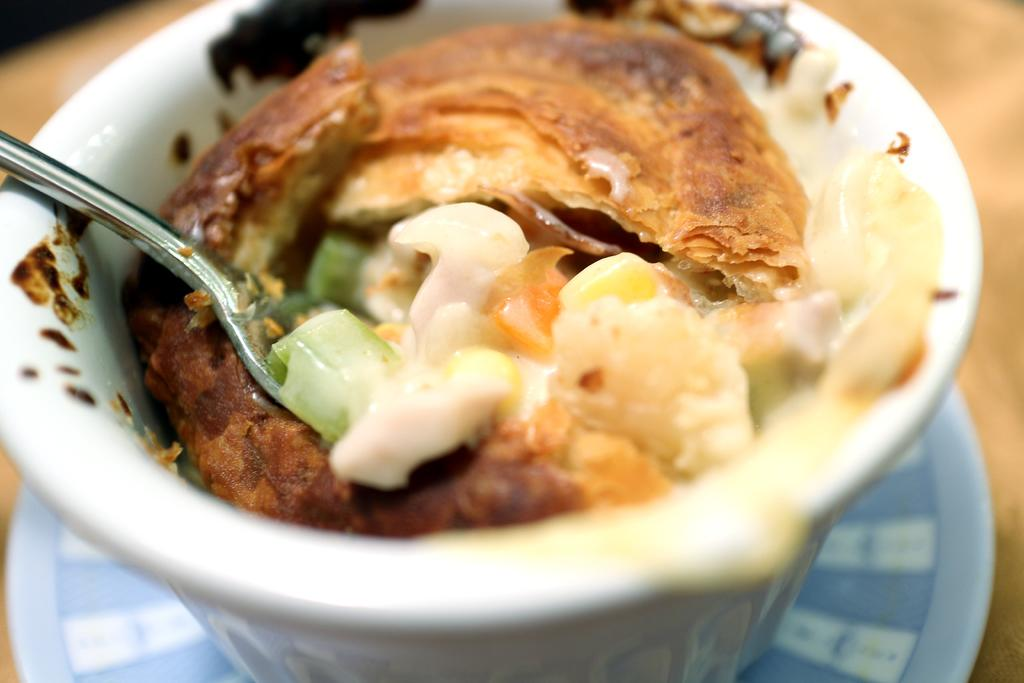What is the main subject in the image? There is a food item in the image. What utensil is present in the image? There is a spoon in the image. What is the food item contained in? There is a bowl in the image. What is the food item placed on? The food item, spoon, bowl, and plate are on a platform. How many clouds can be seen in the image? There are no clouds present in the image. What type of guitar is visible on the platform in the image? There is no guitar present in the image. 